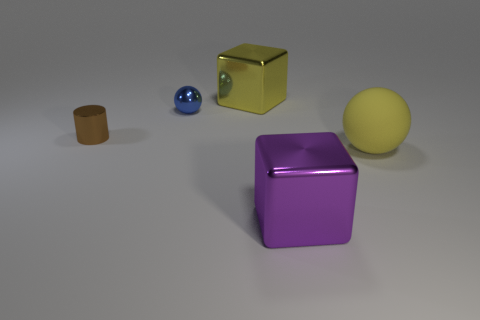Add 2 large purple shiny blocks. How many objects exist? 7 Subtract all cubes. How many objects are left? 3 Add 1 metal blocks. How many metal blocks are left? 3 Add 4 small blue cubes. How many small blue cubes exist? 4 Subtract 0 red cylinders. How many objects are left? 5 Subtract all blue rubber spheres. Subtract all purple things. How many objects are left? 4 